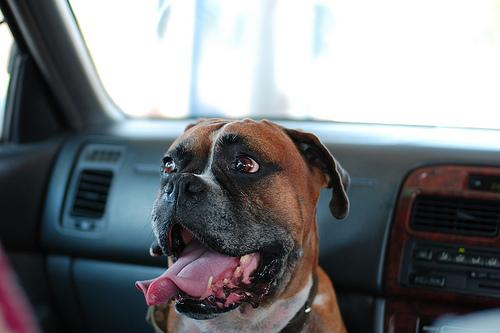Summarize the image by focusing on the dog's face and the car features. A dog with a pink tongue, black nose, and brown eyes is sitting in a car with a wood grain panel, air vent, and green light on the radio. Describe what the dog is doing in the car and its facial features. The dog is sitting in the car, looking to the left with pink tongue out, black nose, brown eyes, and wearing a brown collar. Explain what the dog is doing inside the car and the dog's physical attributes. The dog is seated in the car with its mouth open, exposing a pink tongue, yellow teeth, and wearing a brown leather collar. Describe the appearance and components of the car's interior. The car interior features a black radio, green light on the radio, wood grain panel, air vent, climate control buttons, and a front windshield. Mention the colors and features of the dog inside the car. The dog in the car has brown and black fur, reddish-brown eyes, a black nose, pink tongue, yellow teeth, and is wearing a brown leather collar. Characterize the image by detailing the main aspects of the dog's appearance and the car's interior. The image shows a panting dog with floppy ears, a black nose, and a brown collar inside a car featuring wood grain design, an air vent, and a radio. Write a concise summary of the picture, focusing on the dog and the car. A black and brown dog with a wagging pink tongue sits inside a car with wood grain finishing and various control features. Provide a brief description of the scene captured in the image. A black and brown dog with floppy ears and a pink tongue is sitting inside a car, while sunlight shines through the windshield. Mention the characteristics of the car dashboard and what the dog is doing in the car. The car dashboard has an air vent, wood grain design panel, black radio, and green light. The dog is sitting, panting with its tongue out. Describe the dog's position and facial features in the car. The dog is sitting down inside the car with its tongue out, revealing pink gums, white teeth, and a black nose, accompanied by reddish-brown eyes. 